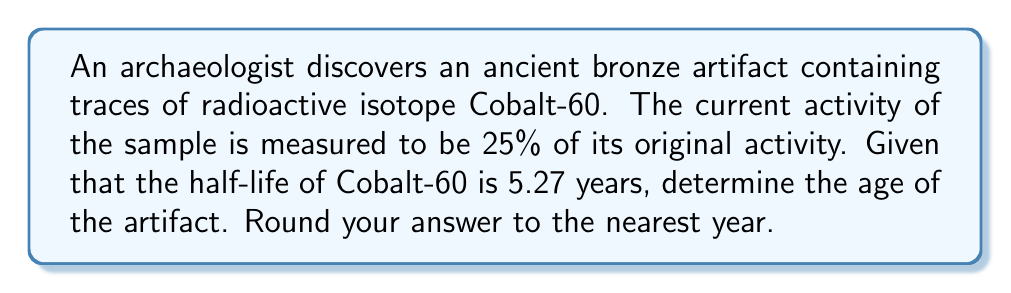Show me your answer to this math problem. Let's approach this step-by-step using the radioactive decay formula:

1) The general formula for radioactive decay is:

   $$A(t) = A_0 \cdot e^{-\lambda t}$$

   Where:
   $A(t)$ is the activity at time $t$
   $A_0$ is the initial activity
   $\lambda$ is the decay constant
   $t$ is the time elapsed

2) We're given that the current activity is 25% of the original, so:

   $$\frac{A(t)}{A_0} = 0.25$$

3) We need to find $\lambda$. For this, we use the half-life formula:

   $$T_{1/2} = \frac{\ln(2)}{\lambda}$$

   Rearranging:

   $$\lambda = \frac{\ln(2)}{T_{1/2}} = \frac{\ln(2)}{5.27} \approx 0.1315 \text{ years}^{-1}$$

4) Now, let's substitute into our original decay formula:

   $$0.25 = e^{-0.1315t}$$

5) Taking natural log of both sides:

   $$\ln(0.25) = -0.1315t$$

6) Solving for $t$:

   $$t = \frac{\ln(0.25)}{-0.1315} \approx 10.54 \text{ years}$$

7) Rounding to the nearest year:

   $$t \approx 11 \text{ years}$$
Answer: 11 years 